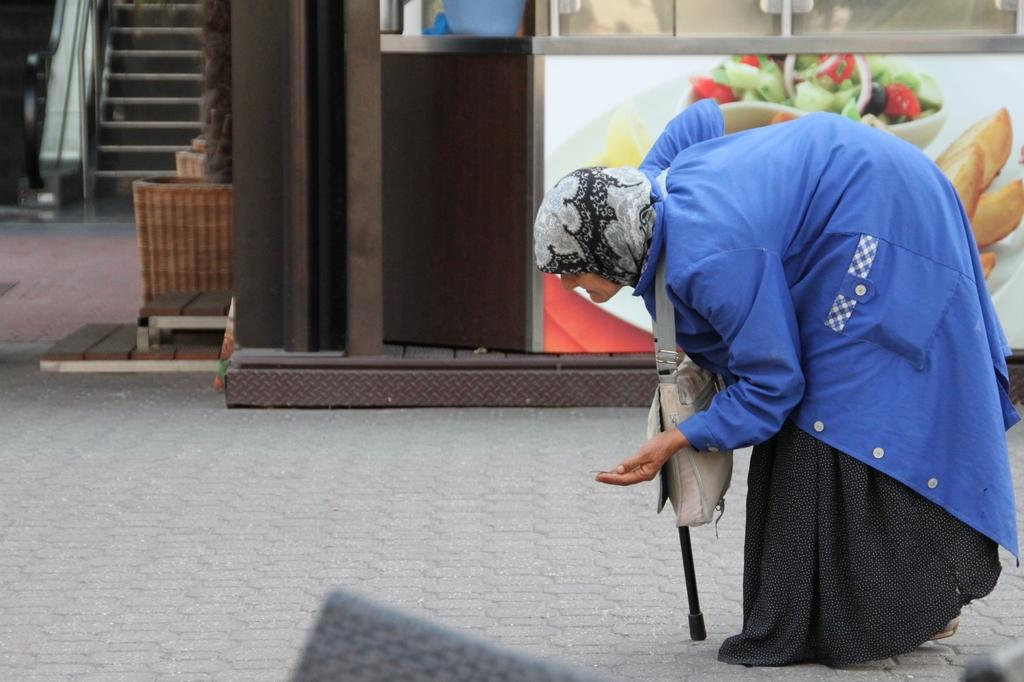Who is present in the image? There is a woman in the image. What is the woman wearing? The woman is wearing a blue jacket. What is the woman doing in the image? The woman is walking on a path. What can be seen in the background of the image? There is a building and a staircase in the background of the image. What is the woman holding in the image? The woman is holding a stick. What type of ticket does the woman need to use the restroom in the image? There is no restroom or ticket present in the image. How does the woman establish a connection with the building in the background? The image does not show any connection being established between the woman and the building. 